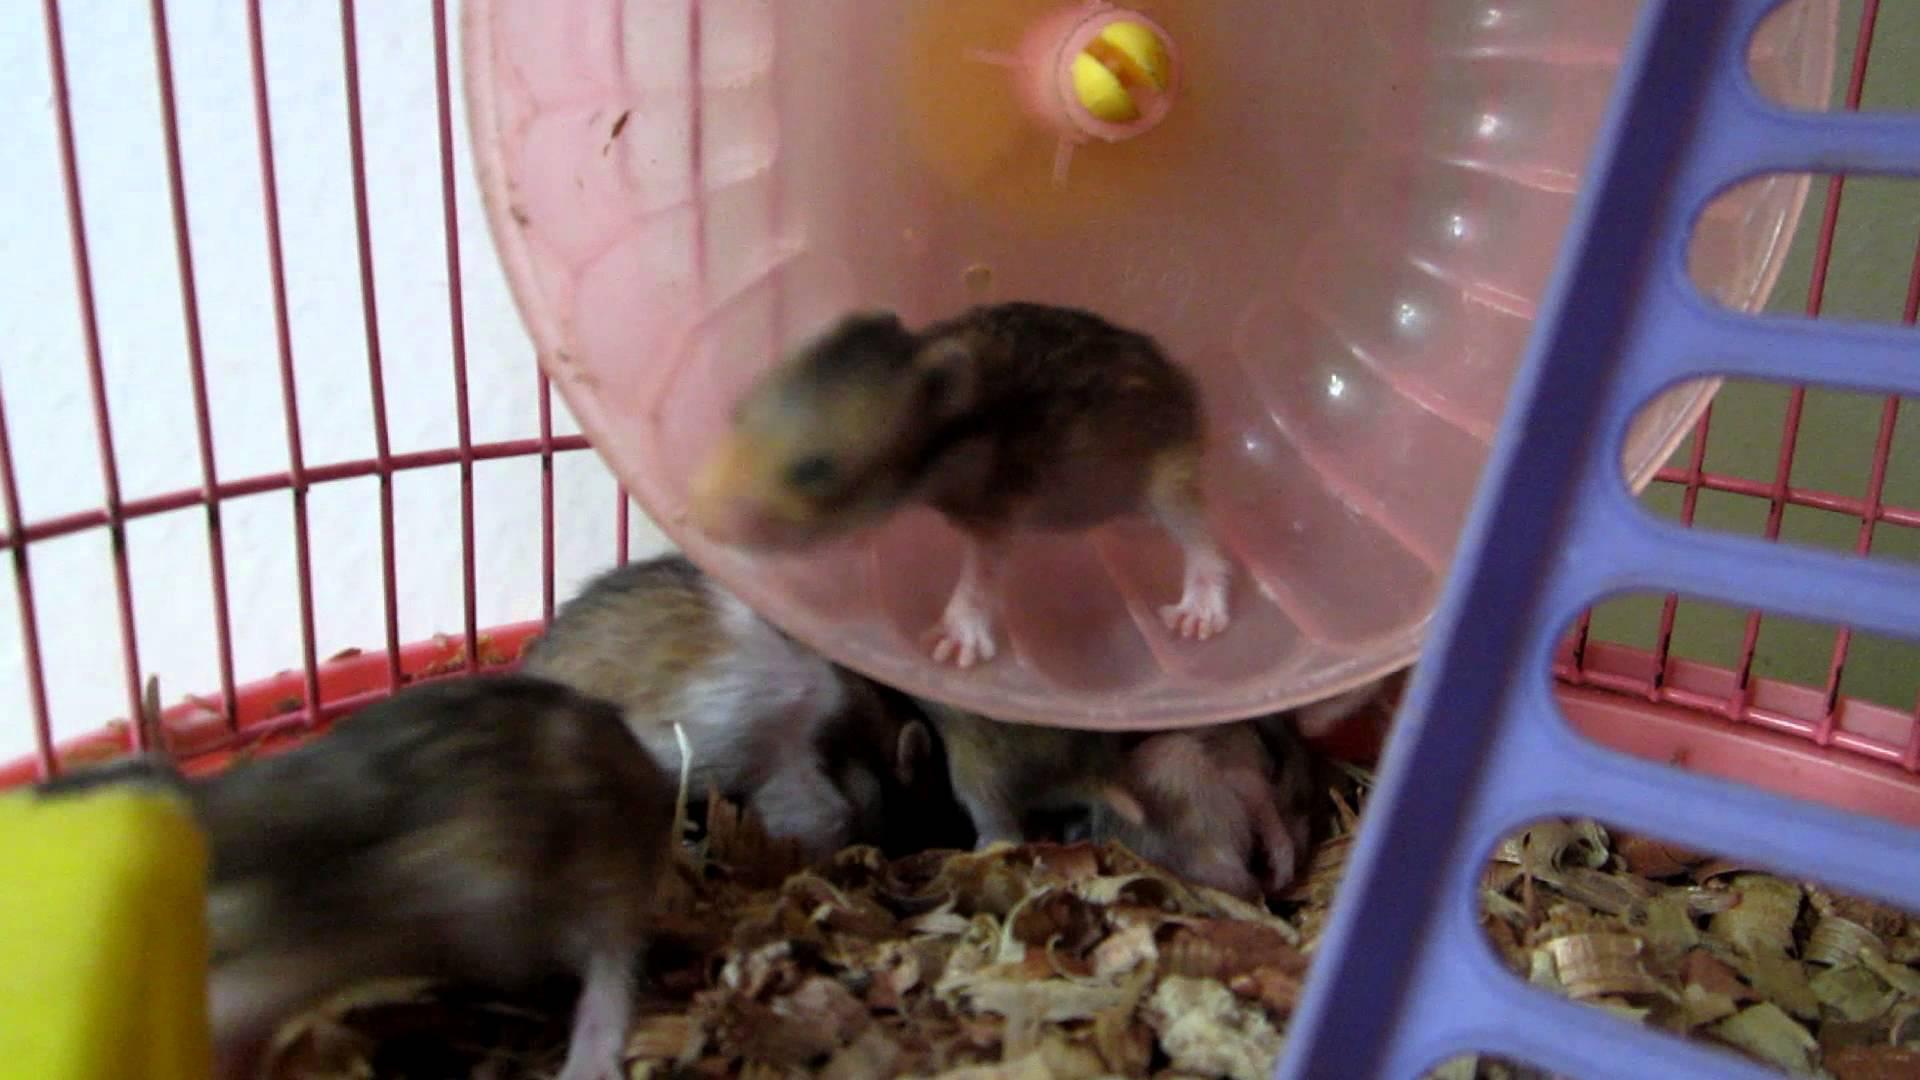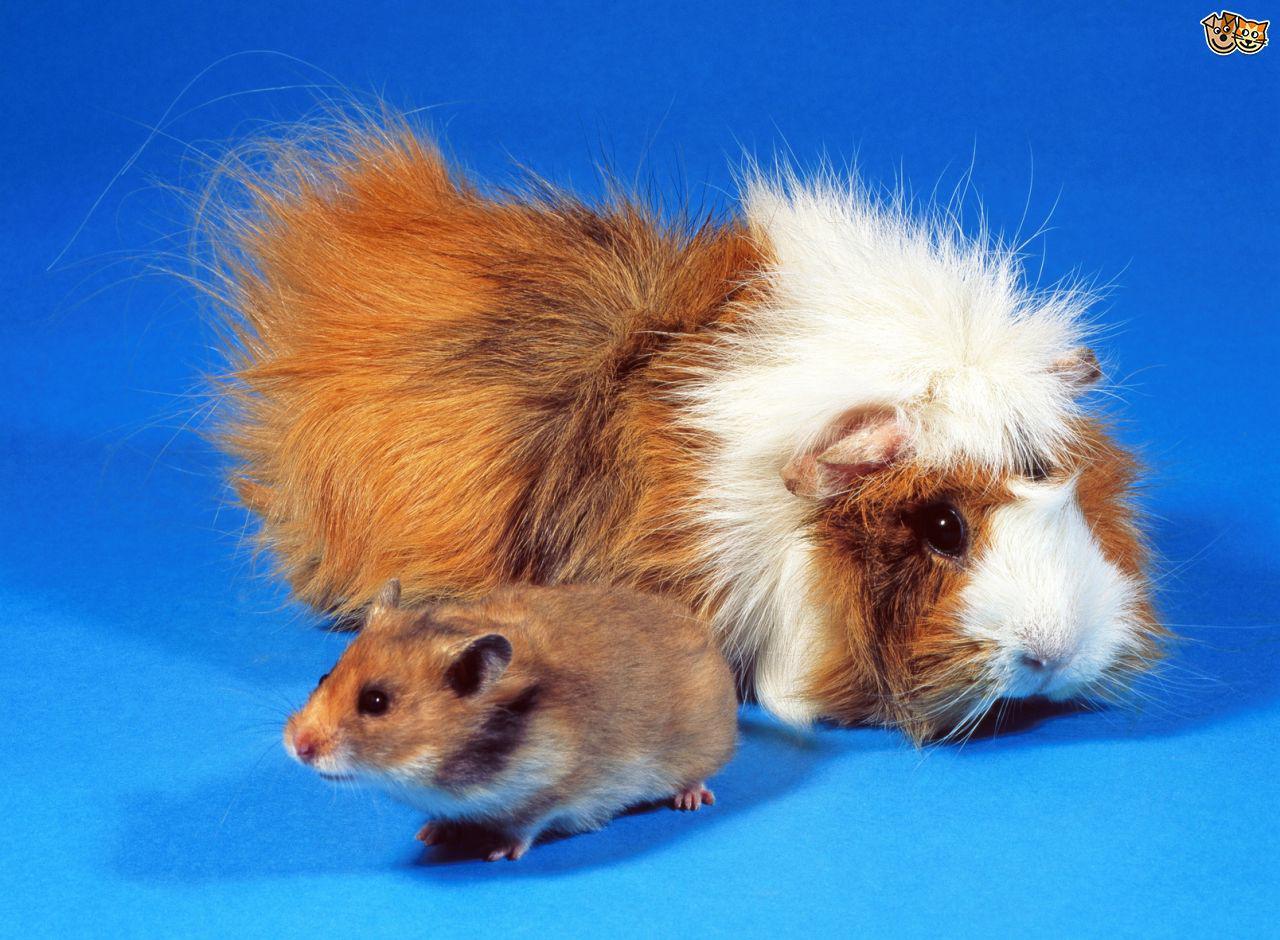The first image is the image on the left, the second image is the image on the right. Examine the images to the left and right. Is the description "The hamster in one of the images is in a wire cage." accurate? Answer yes or no. Yes. The first image is the image on the left, the second image is the image on the right. Examine the images to the left and right. Is the description "An image includes a furry orange-and-white guinea pig near a smaller, shorter-haired rodent." accurate? Answer yes or no. Yes. 